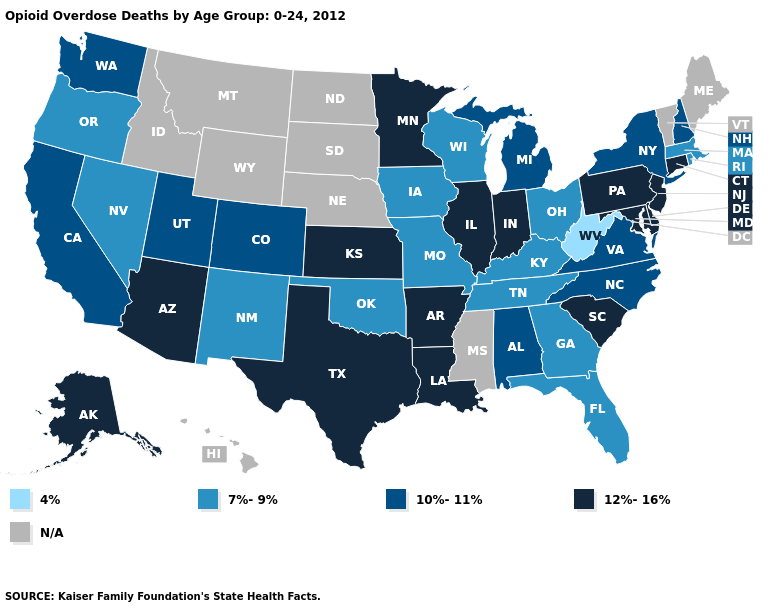Is the legend a continuous bar?
Concise answer only. No. What is the highest value in the South ?
Keep it brief. 12%-16%. Among the states that border North Carolina , which have the highest value?
Write a very short answer. South Carolina. Does Colorado have the lowest value in the West?
Quick response, please. No. What is the highest value in the USA?
Quick response, please. 12%-16%. Does Wisconsin have the lowest value in the MidWest?
Write a very short answer. Yes. Among the states that border Kansas , does Missouri have the lowest value?
Short answer required. Yes. Which states have the lowest value in the South?
Write a very short answer. West Virginia. Name the states that have a value in the range 10%-11%?
Concise answer only. Alabama, California, Colorado, Michigan, New Hampshire, New York, North Carolina, Utah, Virginia, Washington. Among the states that border South Carolina , does Georgia have the lowest value?
Be succinct. Yes. Name the states that have a value in the range 10%-11%?
Concise answer only. Alabama, California, Colorado, Michigan, New Hampshire, New York, North Carolina, Utah, Virginia, Washington. Does West Virginia have the lowest value in the USA?
Concise answer only. Yes. Name the states that have a value in the range 7%-9%?
Concise answer only. Florida, Georgia, Iowa, Kentucky, Massachusetts, Missouri, Nevada, New Mexico, Ohio, Oklahoma, Oregon, Rhode Island, Tennessee, Wisconsin. Which states have the lowest value in the USA?
Short answer required. West Virginia. 